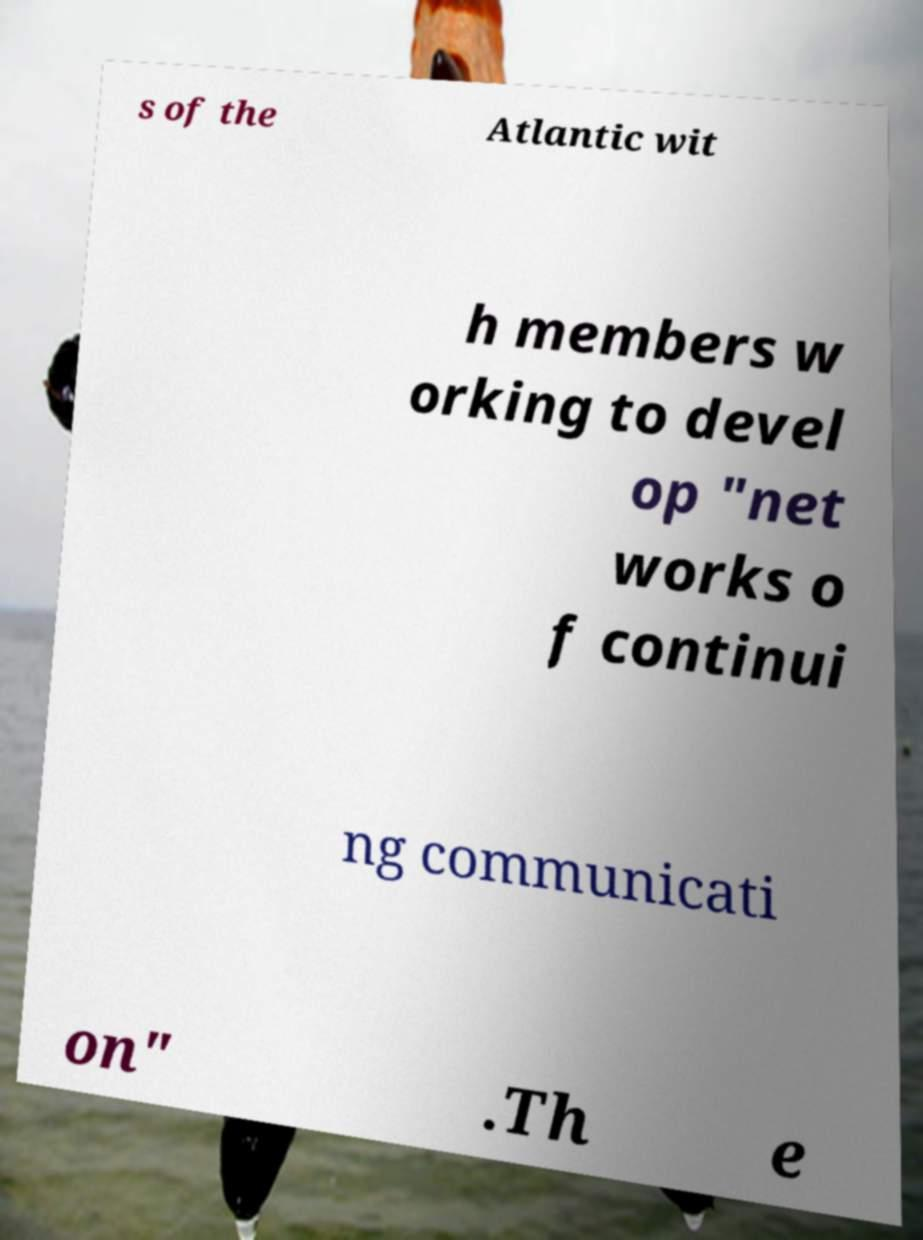Can you accurately transcribe the text from the provided image for me? s of the Atlantic wit h members w orking to devel op "net works o f continui ng communicati on" .Th e 